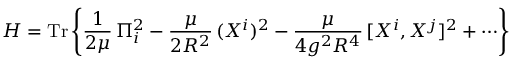Convert formula to latex. <formula><loc_0><loc_0><loc_500><loc_500>H = T r \left \{ \frac { 1 } { 2 \mu } \, \Pi _ { i } ^ { 2 } - \frac { \mu } { 2 R ^ { 2 } } \, ( X ^ { i } ) ^ { 2 } - \frac { \mu } { 4 g ^ { 2 } R ^ { 4 } } \, [ X ^ { i } , X ^ { j } ] ^ { 2 } + \cdots \right \}</formula> 